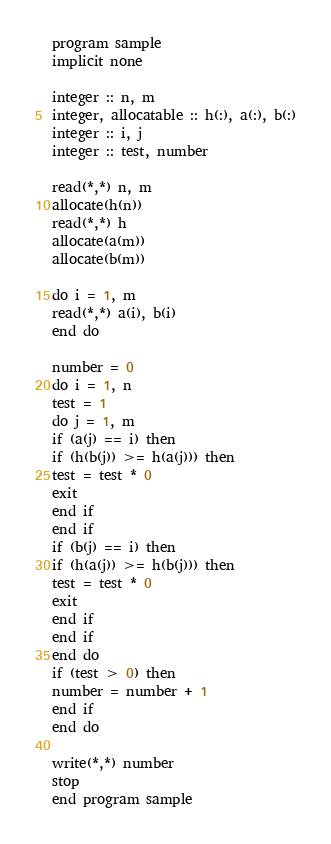<code> <loc_0><loc_0><loc_500><loc_500><_FORTRAN_>program sample
implicit none

integer :: n, m
integer, allocatable :: h(:), a(:), b(:)
integer :: i, j
integer :: test, number

read(*,*) n, m
allocate(h(n))
read(*,*) h
allocate(a(m))
allocate(b(m))

do i = 1, m
read(*,*) a(i), b(i)
end do

number = 0
do i = 1, n
test = 1
do j = 1, m
if (a(j) == i) then
if (h(b(j)) >= h(a(j))) then
test = test * 0
exit
end if
end if
if (b(j) == i) then
if (h(a(j)) >= h(b(j))) then
test = test * 0
exit
end if
end if
end do
if (test > 0) then
number = number + 1
end if
end do

write(*,*) number
stop
end program sample</code> 